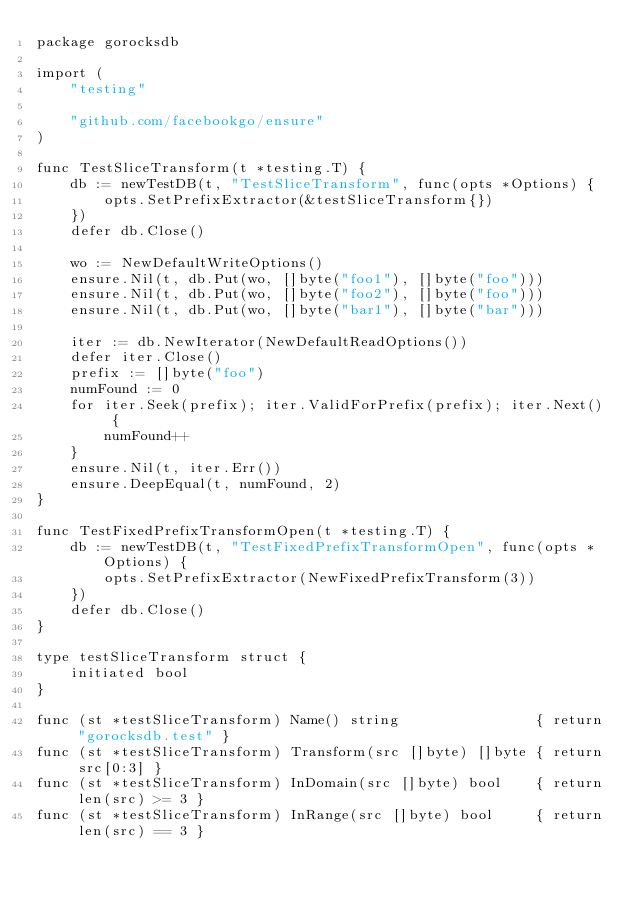<code> <loc_0><loc_0><loc_500><loc_500><_Go_>package gorocksdb

import (
	"testing"

	"github.com/facebookgo/ensure"
)

func TestSliceTransform(t *testing.T) {
	db := newTestDB(t, "TestSliceTransform", func(opts *Options) {
		opts.SetPrefixExtractor(&testSliceTransform{})
	})
	defer db.Close()

	wo := NewDefaultWriteOptions()
	ensure.Nil(t, db.Put(wo, []byte("foo1"), []byte("foo")))
	ensure.Nil(t, db.Put(wo, []byte("foo2"), []byte("foo")))
	ensure.Nil(t, db.Put(wo, []byte("bar1"), []byte("bar")))

	iter := db.NewIterator(NewDefaultReadOptions())
	defer iter.Close()
	prefix := []byte("foo")
	numFound := 0
	for iter.Seek(prefix); iter.ValidForPrefix(prefix); iter.Next() {
		numFound++
	}
	ensure.Nil(t, iter.Err())
	ensure.DeepEqual(t, numFound, 2)
}

func TestFixedPrefixTransformOpen(t *testing.T) {
	db := newTestDB(t, "TestFixedPrefixTransformOpen", func(opts *Options) {
		opts.SetPrefixExtractor(NewFixedPrefixTransform(3))
	})
	defer db.Close()
}

type testSliceTransform struct {
	initiated bool
}

func (st *testSliceTransform) Name() string                { return "gorocksdb.test" }
func (st *testSliceTransform) Transform(src []byte) []byte { return src[0:3] }
func (st *testSliceTransform) InDomain(src []byte) bool    { return len(src) >= 3 }
func (st *testSliceTransform) InRange(src []byte) bool     { return len(src) == 3 }
</code> 